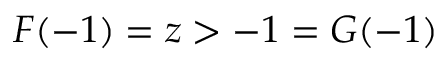Convert formula to latex. <formula><loc_0><loc_0><loc_500><loc_500>F ( - 1 ) = z > - 1 = G ( - 1 )</formula> 